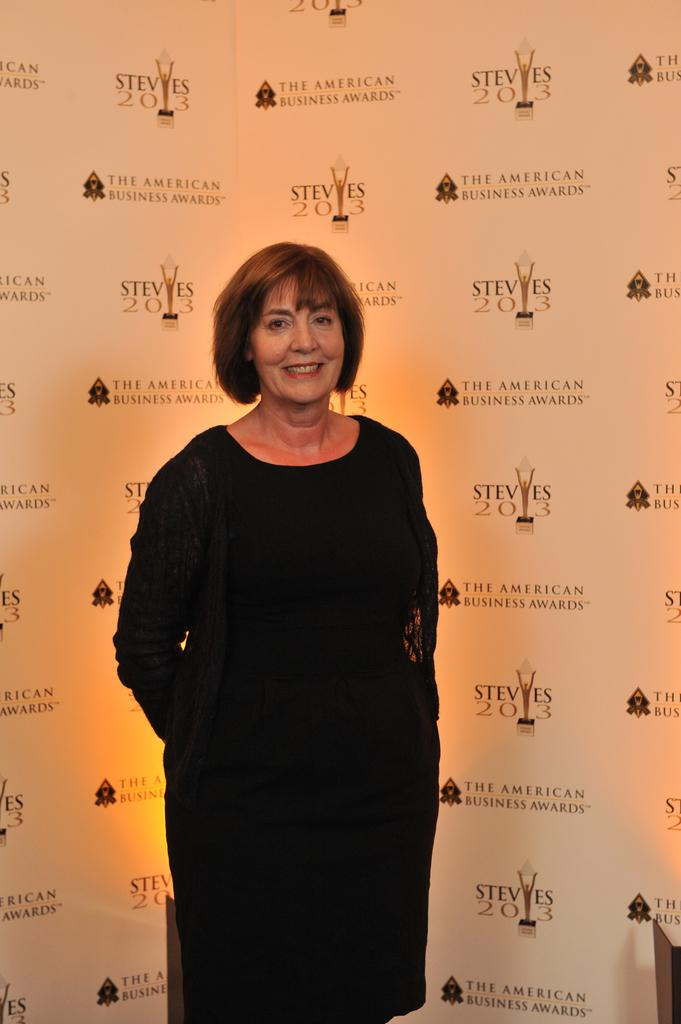Who or what is present in the image? There is a person in the image. What is the person doing in the image? The person is standing. What is the person wearing in the image? The person is wearing clothes. What type of giraffe can be seen walking down the street in the image? There is no giraffe or street present in the image; it features a person standing and wearing clothes. 